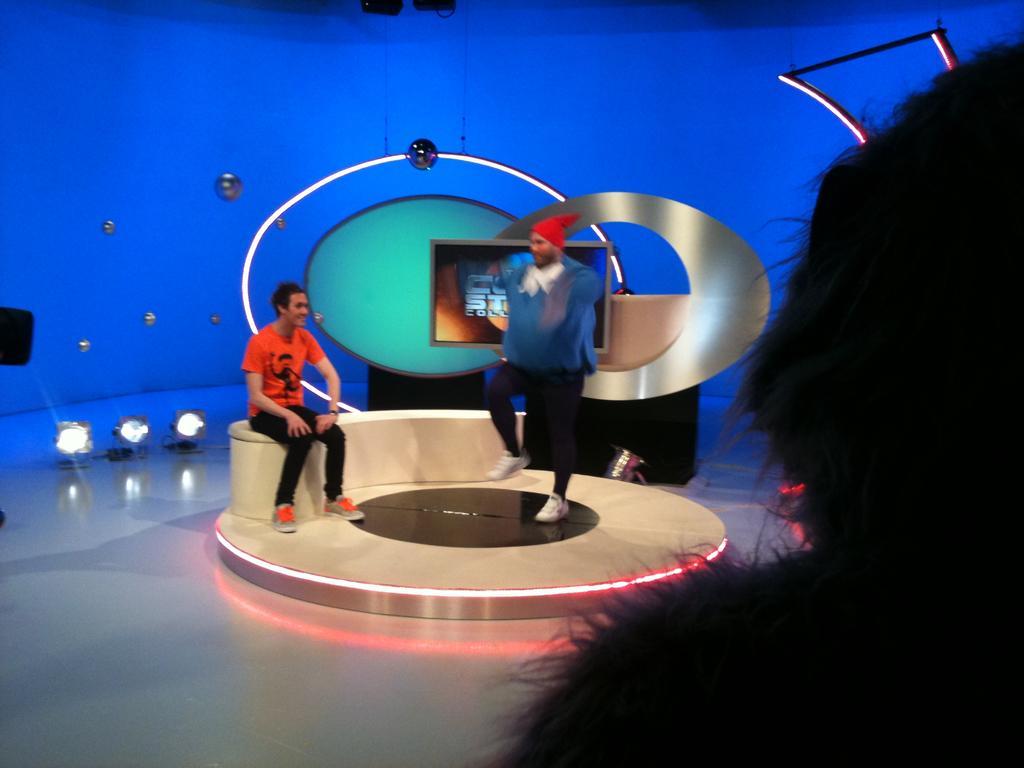How would you summarize this image in a sentence or two? In this image I can see one person is standing and one person is sitting. Back I can see few objects and blue color background. I can see few lights and black color object in front. 